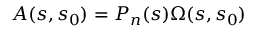<formula> <loc_0><loc_0><loc_500><loc_500>A ( s , s _ { 0 } ) = P _ { n } ( s ) \Omega ( s , s _ { 0 } )</formula> 